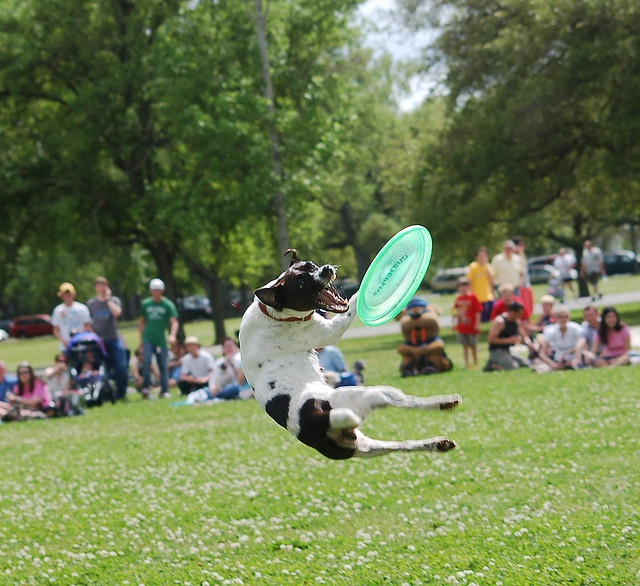Describe the objects in this image and their specific colors. I can see dog in green, darkgray, black, lightgray, and olive tones, people in green, darkgray, gray, black, and olive tones, frisbee in green, aquamarine, and beige tones, people in green, teal, gray, darkgreen, and black tones, and people in green, gray, black, navy, and darkgray tones in this image. 